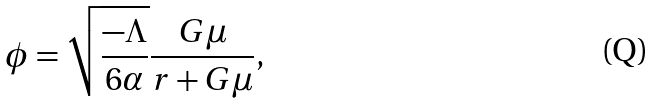Convert formula to latex. <formula><loc_0><loc_0><loc_500><loc_500>\phi = \sqrt { \frac { - \Lambda } { 6 \alpha } } \frac { G \mu } { r + G \mu } ,</formula> 